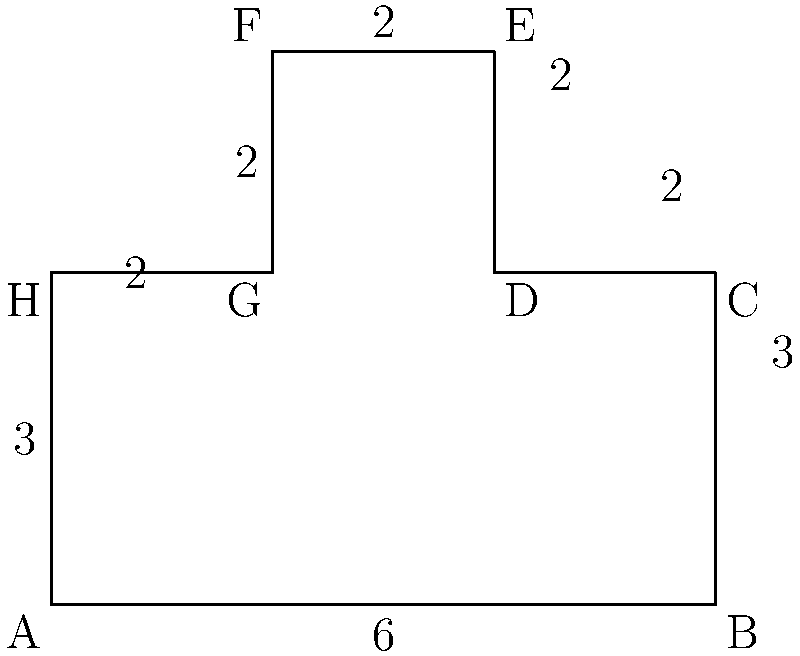The Wallingford Community Park has an irregular shape as shown in the diagram. As part of a local initiative to improve public spaces, you've been asked to calculate the perimeter of the park for a new jogging trail. Given the measurements in the diagram (in hundreds of feet), what is the total perimeter of the park in feet? To find the perimeter of the irregularly shaped park, we need to sum up all the side lengths:

1. Bottom side (AB): 6 hundred feet = 600 feet
2. Right side (BC + CD + DE): (3 + 2 + 2) hundred feet = 700 feet
3. Top side (EF): 2 hundred feet = 200 feet
4. Left side (FG + GH + HA): (2 + 2 + 3) hundred feet = 700 feet

Now, let's add all these lengths:

$$ \text{Perimeter} = 600 + 700 + 200 + 700 = 2200 \text{ feet} $$

Therefore, the total perimeter of the Wallingford Community Park is 2200 feet.
Answer: 2200 feet 